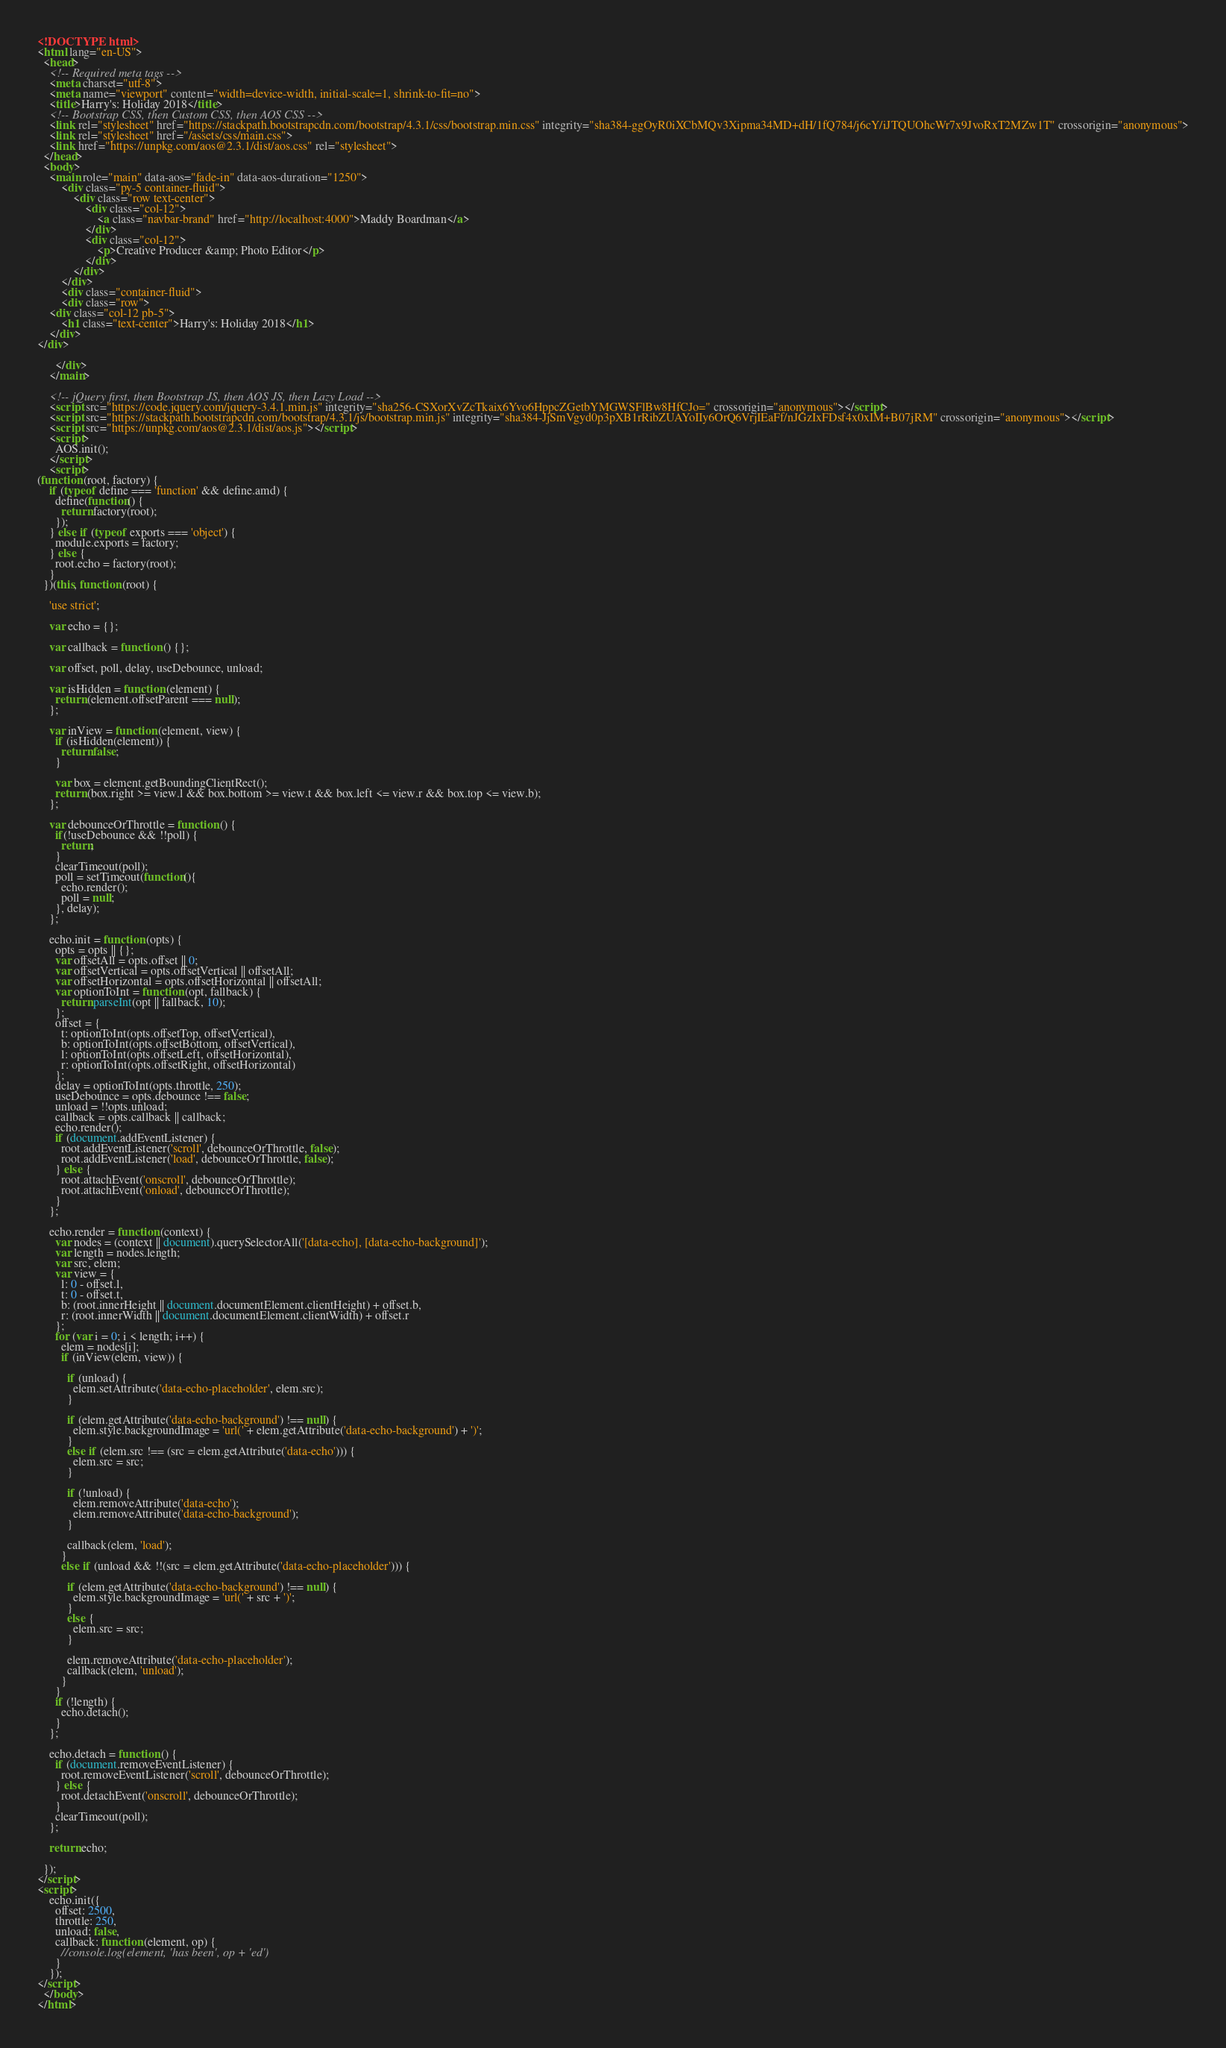<code> <loc_0><loc_0><loc_500><loc_500><_HTML_><!DOCTYPE html>
<html lang="en-US">
  <head>
    <!-- Required meta tags -->
    <meta charset="utf-8">
    <meta name="viewport" content="width=device-width, initial-scale=1, shrink-to-fit=no">
    <title>Harry's: Holiday 2018</title>
    <!-- Bootstrap CSS, then Custom CSS, then AOS CSS -->
    <link rel="stylesheet" href="https://stackpath.bootstrapcdn.com/bootstrap/4.3.1/css/bootstrap.min.css" integrity="sha384-ggOyR0iXCbMQv3Xipma34MD+dH/1fQ784/j6cY/iJTQUOhcWr7x9JvoRxT2MZw1T" crossorigin="anonymous">
    <link rel="stylesheet" href="/assets/css/main.css">
    <link href="https://unpkg.com/aos@2.3.1/dist/aos.css" rel="stylesheet">
  </head>
  <body>
    <main role="main" data-aos="fade-in" data-aos-duration="1250">
    	<div class="py-5 container-fluid">
    		<div class="row text-center">
    			<div class="col-12">
    				<a class="navbar-brand" href="http://localhost:4000">Maddy Boardman</a>
    			</div>
    			<div class="col-12">
    				<p>Creative Producer &amp; Photo Editor</p>
    			</div>
    		</div>
  		</div>
  		<div class="container-fluid">
      	<div class="row">
	<div class="col-12 pb-5">
		<h1 class="text-center">Harry's: Holiday 2018</h1>
	</div>
</div>

      </div>
    </main>

    <!-- jQuery first, then Bootstrap JS, then AOS JS, then Lazy Load -->
    <script src="https://code.jquery.com/jquery-3.4.1.min.js" integrity="sha256-CSXorXvZcTkaix6Yvo6HppcZGetbYMGWSFlBw8HfCJo=" crossorigin="anonymous"></script>
    <script src="https://stackpath.bootstrapcdn.com/bootstrap/4.3.1/js/bootstrap.min.js" integrity="sha384-JjSmVgyd0p3pXB1rRibZUAYoIIy6OrQ6VrjIEaFf/nJGzIxFDsf4x0xIM+B07jRM" crossorigin="anonymous"></script>
    <script src="https://unpkg.com/aos@2.3.1/dist/aos.js"></script>
    <script>
      AOS.init();
    </script>
    <script>
(function (root, factory) {
    if (typeof define === 'function' && define.amd) {
      define(function() {
        return factory(root);
      });
    } else if (typeof exports === 'object') {
      module.exports = factory;
    } else {
      root.echo = factory(root);
    }
  })(this, function (root) {
  
    'use strict';
  
    var echo = {};
  
    var callback = function () {};
  
    var offset, poll, delay, useDebounce, unload;
  
    var isHidden = function (element) {
      return (element.offsetParent === null);
    };
    
    var inView = function (element, view) {
      if (isHidden(element)) {
        return false;
      }
  
      var box = element.getBoundingClientRect();
      return (box.right >= view.l && box.bottom >= view.t && box.left <= view.r && box.top <= view.b);
    };
  
    var debounceOrThrottle = function () {
      if(!useDebounce && !!poll) {
        return;
      }
      clearTimeout(poll);
      poll = setTimeout(function(){
        echo.render();
        poll = null;
      }, delay);
    };
  
    echo.init = function (opts) {
      opts = opts || {};
      var offsetAll = opts.offset || 0;
      var offsetVertical = opts.offsetVertical || offsetAll;
      var offsetHorizontal = opts.offsetHorizontal || offsetAll;
      var optionToInt = function (opt, fallback) {
        return parseInt(opt || fallback, 10);
      };
      offset = {
        t: optionToInt(opts.offsetTop, offsetVertical),
        b: optionToInt(opts.offsetBottom, offsetVertical),
        l: optionToInt(opts.offsetLeft, offsetHorizontal),
        r: optionToInt(opts.offsetRight, offsetHorizontal)
      };
      delay = optionToInt(opts.throttle, 250);
      useDebounce = opts.debounce !== false;
      unload = !!opts.unload;
      callback = opts.callback || callback;
      echo.render();
      if (document.addEventListener) {
        root.addEventListener('scroll', debounceOrThrottle, false);
        root.addEventListener('load', debounceOrThrottle, false);
      } else {
        root.attachEvent('onscroll', debounceOrThrottle);
        root.attachEvent('onload', debounceOrThrottle);
      }
    };
  
    echo.render = function (context) {
      var nodes = (context || document).querySelectorAll('[data-echo], [data-echo-background]');
      var length = nodes.length;
      var src, elem;
      var view = {
        l: 0 - offset.l,
        t: 0 - offset.t,
        b: (root.innerHeight || document.documentElement.clientHeight) + offset.b,
        r: (root.innerWidth || document.documentElement.clientWidth) + offset.r
      };
      for (var i = 0; i < length; i++) {
        elem = nodes[i];
        if (inView(elem, view)) {
  
          if (unload) {
            elem.setAttribute('data-echo-placeholder', elem.src);
          }
  
          if (elem.getAttribute('data-echo-background') !== null) {
            elem.style.backgroundImage = 'url(' + elem.getAttribute('data-echo-background') + ')';
          }
          else if (elem.src !== (src = elem.getAttribute('data-echo'))) {
            elem.src = src;
          }
  
          if (!unload) {
            elem.removeAttribute('data-echo');
            elem.removeAttribute('data-echo-background');
          }
  
          callback(elem, 'load');
        }
        else if (unload && !!(src = elem.getAttribute('data-echo-placeholder'))) {
  
          if (elem.getAttribute('data-echo-background') !== null) {
            elem.style.backgroundImage = 'url(' + src + ')';
          }
          else {
            elem.src = src;
          }
  
          elem.removeAttribute('data-echo-placeholder');
          callback(elem, 'unload');
        }
      }
      if (!length) {
        echo.detach();
      }
    };
  
    echo.detach = function () {
      if (document.removeEventListener) {
        root.removeEventListener('scroll', debounceOrThrottle);
      } else {
        root.detachEvent('onscroll', debounceOrThrottle);
      }
      clearTimeout(poll);
    };
  
    return echo;
  
  });
</script>
<script>
    echo.init({
      offset: 2500,
      throttle: 250,
      unload: false,
      callback: function (element, op) {
        //console.log(element, 'has been', op + 'ed')
      }
    });
</script>
  </body>
</html>
</code> 